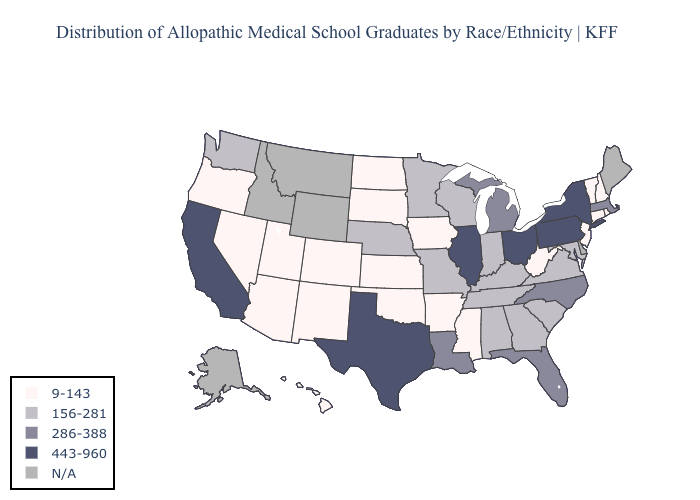Which states have the lowest value in the South?
Keep it brief. Arkansas, Mississippi, Oklahoma, West Virginia. What is the value of Nevada?
Short answer required. 9-143. Which states hav the highest value in the MidWest?
Be succinct. Illinois, Ohio. Name the states that have a value in the range 443-960?
Keep it brief. California, Illinois, New York, Ohio, Pennsylvania, Texas. Does the map have missing data?
Short answer required. Yes. What is the value of Colorado?
Quick response, please. 9-143. What is the value of Tennessee?
Answer briefly. 156-281. What is the value of Idaho?
Answer briefly. N/A. Name the states that have a value in the range 286-388?
Short answer required. Florida, Louisiana, Massachusetts, Michigan, North Carolina. What is the highest value in states that border Delaware?
Answer briefly. 443-960. Name the states that have a value in the range N/A?
Concise answer only. Alaska, Delaware, Idaho, Maine, Montana, Wyoming. What is the lowest value in the USA?
Concise answer only. 9-143. Name the states that have a value in the range 156-281?
Give a very brief answer. Alabama, Georgia, Indiana, Kentucky, Maryland, Minnesota, Missouri, Nebraska, South Carolina, Tennessee, Virginia, Washington, Wisconsin. 